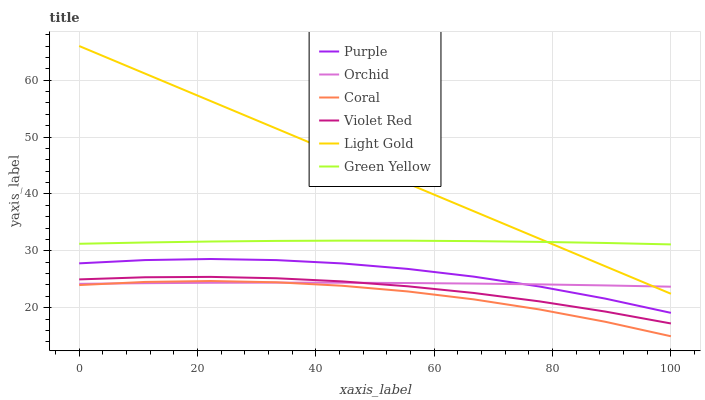Does Coral have the minimum area under the curve?
Answer yes or no. Yes. Does Light Gold have the maximum area under the curve?
Answer yes or no. Yes. Does Purple have the minimum area under the curve?
Answer yes or no. No. Does Purple have the maximum area under the curve?
Answer yes or no. No. Is Light Gold the smoothest?
Answer yes or no. Yes. Is Coral the roughest?
Answer yes or no. Yes. Is Purple the smoothest?
Answer yes or no. No. Is Purple the roughest?
Answer yes or no. No. Does Coral have the lowest value?
Answer yes or no. Yes. Does Purple have the lowest value?
Answer yes or no. No. Does Light Gold have the highest value?
Answer yes or no. Yes. Does Purple have the highest value?
Answer yes or no. No. Is Violet Red less than Green Yellow?
Answer yes or no. Yes. Is Purple greater than Violet Red?
Answer yes or no. Yes. Does Orchid intersect Light Gold?
Answer yes or no. Yes. Is Orchid less than Light Gold?
Answer yes or no. No. Is Orchid greater than Light Gold?
Answer yes or no. No. Does Violet Red intersect Green Yellow?
Answer yes or no. No. 